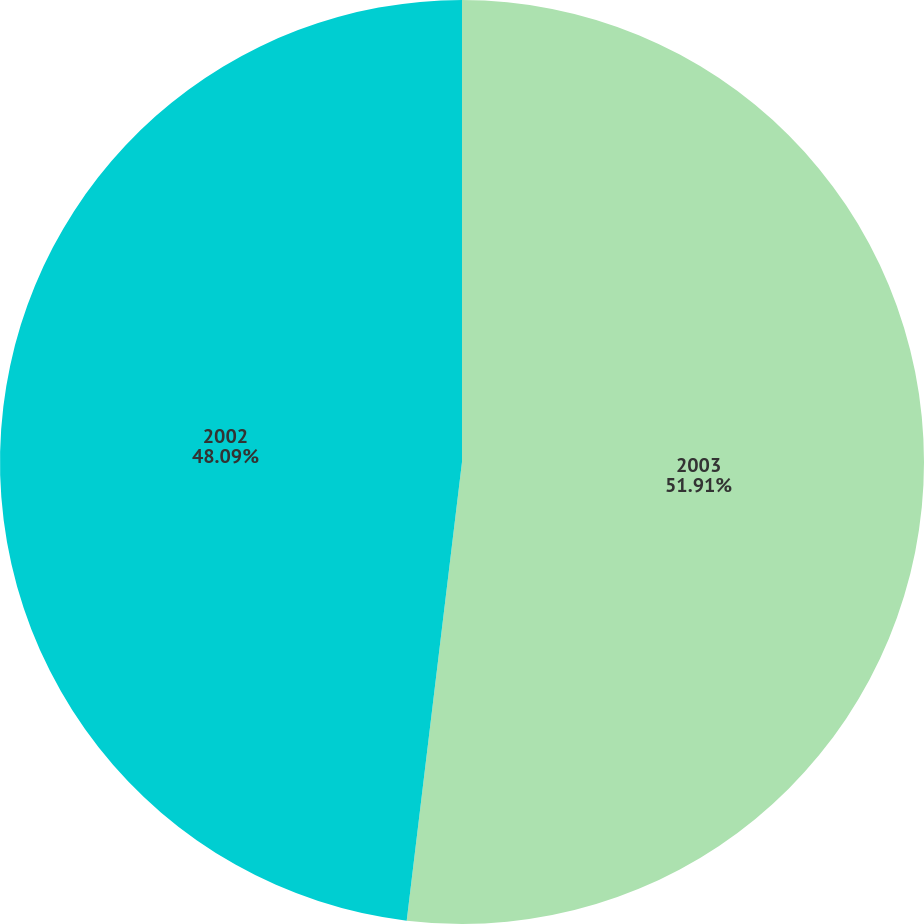Convert chart. <chart><loc_0><loc_0><loc_500><loc_500><pie_chart><fcel>2003<fcel>2002<nl><fcel>51.91%<fcel>48.09%<nl></chart> 